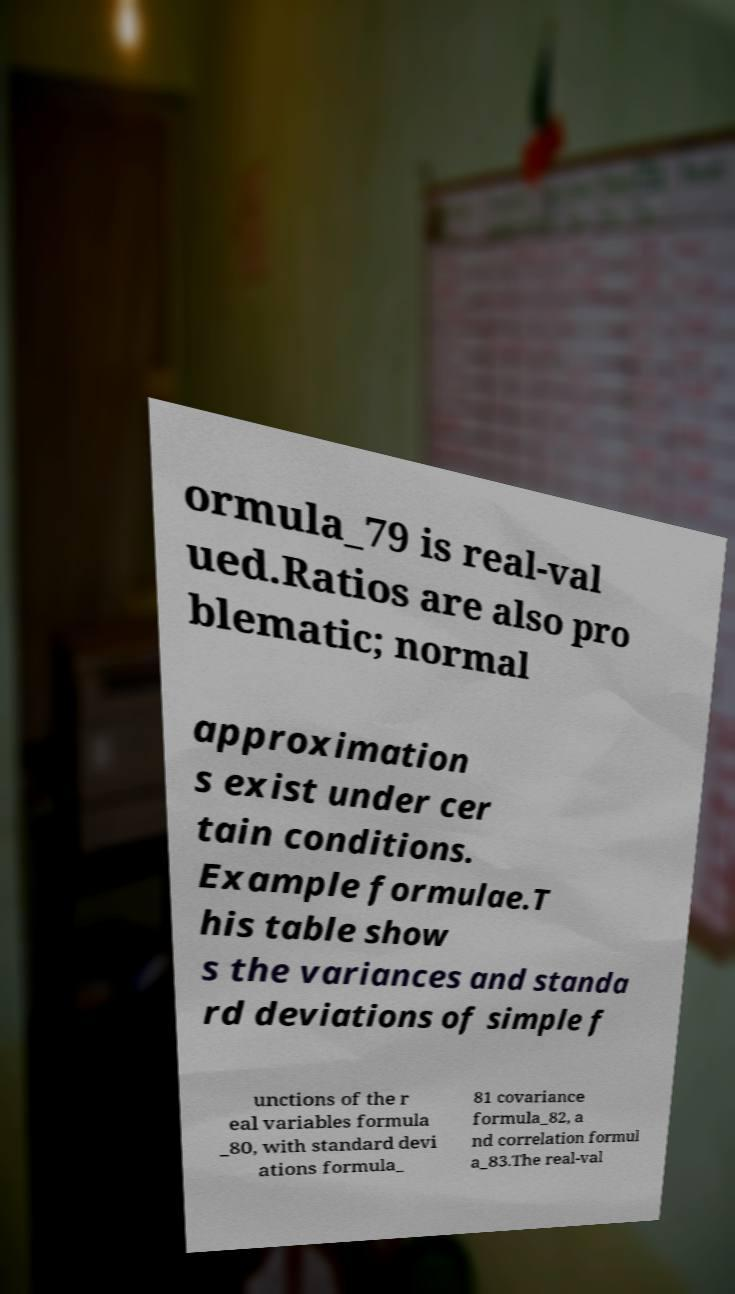I need the written content from this picture converted into text. Can you do that? ormula_79 is real-val ued.Ratios are also pro blematic; normal approximation s exist under cer tain conditions. Example formulae.T his table show s the variances and standa rd deviations of simple f unctions of the r eal variables formula _80, with standard devi ations formula_ 81 covariance formula_82, a nd correlation formul a_83.The real-val 